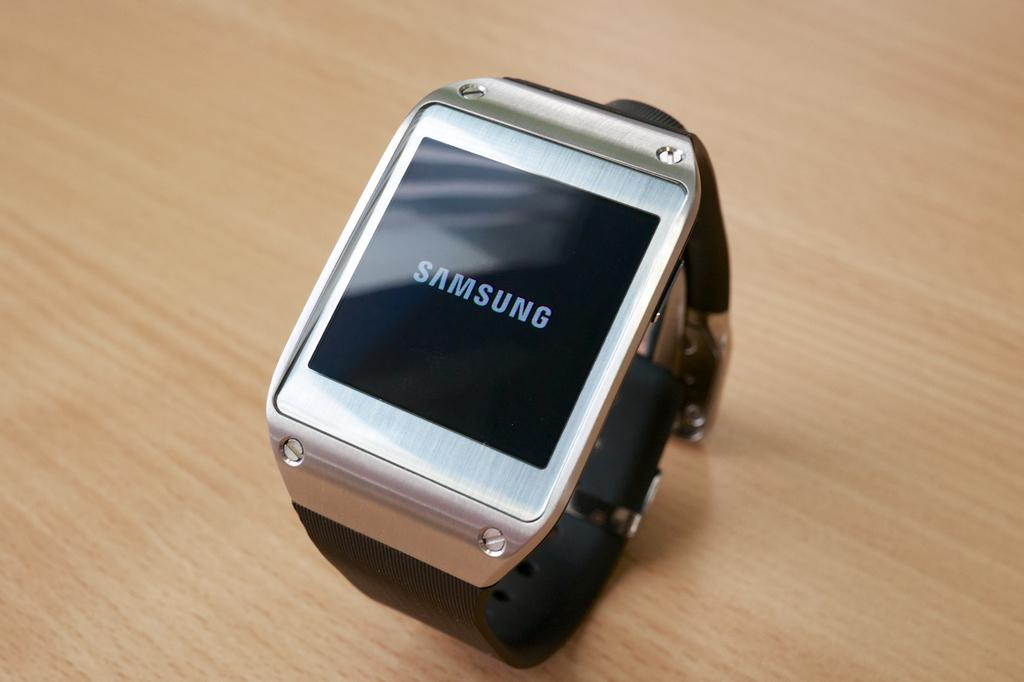<image>
Summarize the visual content of the image. A Samsung  watching sits on a table curled up 